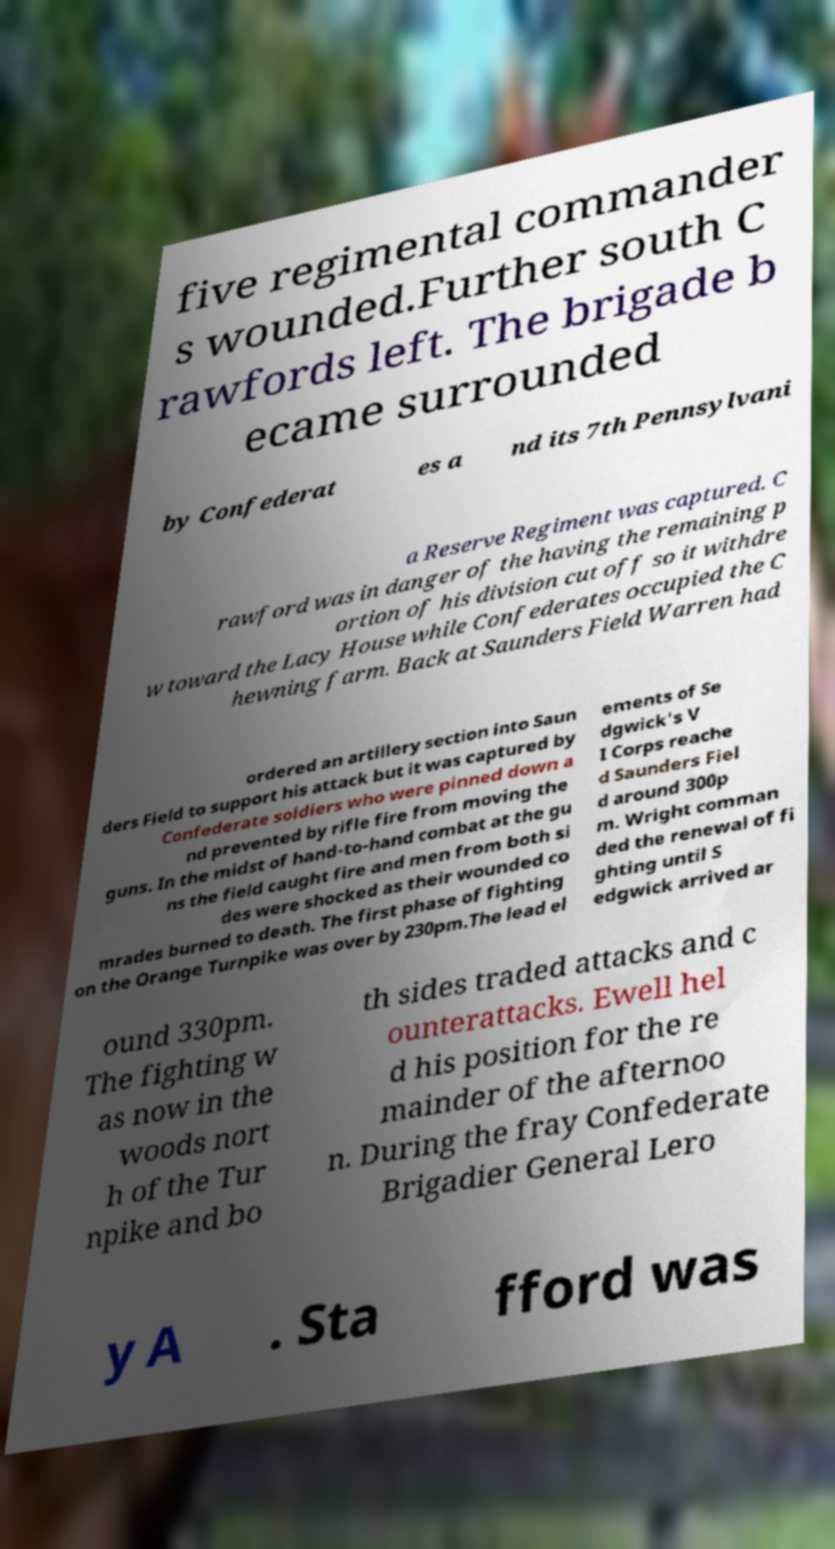Can you read and provide the text displayed in the image?This photo seems to have some interesting text. Can you extract and type it out for me? five regimental commander s wounded.Further south C rawfords left. The brigade b ecame surrounded by Confederat es a nd its 7th Pennsylvani a Reserve Regiment was captured. C rawford was in danger of the having the remaining p ortion of his division cut off so it withdre w toward the Lacy House while Confederates occupied the C hewning farm. Back at Saunders Field Warren had ordered an artillery section into Saun ders Field to support his attack but it was captured by Confederate soldiers who were pinned down a nd prevented by rifle fire from moving the guns. In the midst of hand-to-hand combat at the gu ns the field caught fire and men from both si des were shocked as their wounded co mrades burned to death. The first phase of fighting on the Orange Turnpike was over by 230pm.The lead el ements of Se dgwick's V I Corps reache d Saunders Fiel d around 300p m. Wright comman ded the renewal of fi ghting until S edgwick arrived ar ound 330pm. The fighting w as now in the woods nort h of the Tur npike and bo th sides traded attacks and c ounterattacks. Ewell hel d his position for the re mainder of the afternoo n. During the fray Confederate Brigadier General Lero y A . Sta fford was 